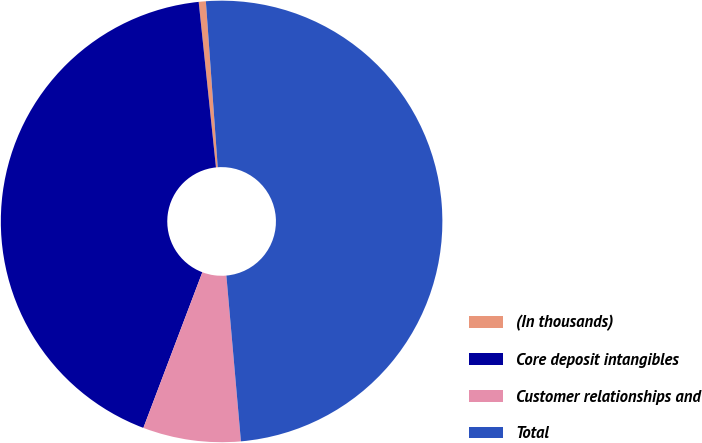Convert chart to OTSL. <chart><loc_0><loc_0><loc_500><loc_500><pie_chart><fcel>(In thousands)<fcel>Core deposit intangibles<fcel>Customer relationships and<fcel>Total<nl><fcel>0.52%<fcel>42.58%<fcel>7.16%<fcel>49.74%<nl></chart> 